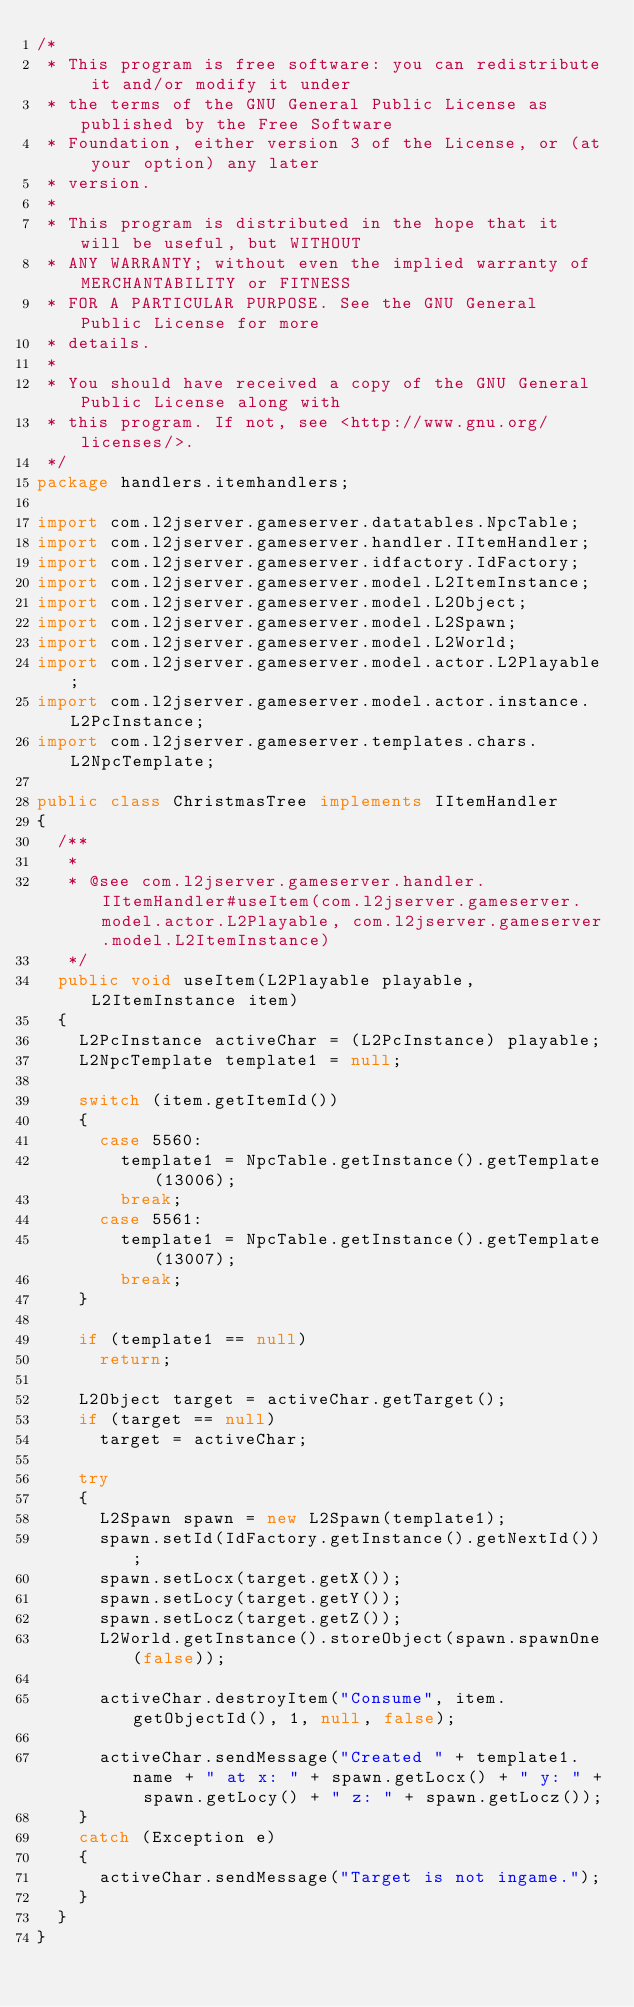<code> <loc_0><loc_0><loc_500><loc_500><_Java_>/*
 * This program is free software: you can redistribute it and/or modify it under
 * the terms of the GNU General Public License as published by the Free Software
 * Foundation, either version 3 of the License, or (at your option) any later
 * version.
 * 
 * This program is distributed in the hope that it will be useful, but WITHOUT
 * ANY WARRANTY; without even the implied warranty of MERCHANTABILITY or FITNESS
 * FOR A PARTICULAR PURPOSE. See the GNU General Public License for more
 * details.
 * 
 * You should have received a copy of the GNU General Public License along with
 * this program. If not, see <http://www.gnu.org/licenses/>.
 */
package handlers.itemhandlers;

import com.l2jserver.gameserver.datatables.NpcTable;
import com.l2jserver.gameserver.handler.IItemHandler;
import com.l2jserver.gameserver.idfactory.IdFactory;
import com.l2jserver.gameserver.model.L2ItemInstance;
import com.l2jserver.gameserver.model.L2Object;
import com.l2jserver.gameserver.model.L2Spawn;
import com.l2jserver.gameserver.model.L2World;
import com.l2jserver.gameserver.model.actor.L2Playable;
import com.l2jserver.gameserver.model.actor.instance.L2PcInstance;
import com.l2jserver.gameserver.templates.chars.L2NpcTemplate;

public class ChristmasTree implements IItemHandler
{
	/**
	 * 
	 * @see com.l2jserver.gameserver.handler.IItemHandler#useItem(com.l2jserver.gameserver.model.actor.L2Playable, com.l2jserver.gameserver.model.L2ItemInstance)
	 */
	public void useItem(L2Playable playable, L2ItemInstance item)
	{
		L2PcInstance activeChar = (L2PcInstance) playable;
		L2NpcTemplate template1 = null;
		
		switch (item.getItemId())
		{
			case 5560:
				template1 = NpcTable.getInstance().getTemplate(13006);
				break;
			case 5561:
				template1 = NpcTable.getInstance().getTemplate(13007);
				break;
		}
		
		if (template1 == null)
			return;
		
		L2Object target = activeChar.getTarget();
		if (target == null)
			target = activeChar;
		
		try
		{
			L2Spawn spawn = new L2Spawn(template1);
			spawn.setId(IdFactory.getInstance().getNextId());
			spawn.setLocx(target.getX());
			spawn.setLocy(target.getY());
			spawn.setLocz(target.getZ());
			L2World.getInstance().storeObject(spawn.spawnOne(false));
			
			activeChar.destroyItem("Consume", item.getObjectId(), 1, null, false);
			
			activeChar.sendMessage("Created " + template1.name + " at x: " + spawn.getLocx() + " y: " + spawn.getLocy() + " z: " + spawn.getLocz());
		}
		catch (Exception e)
		{
			activeChar.sendMessage("Target is not ingame.");
		}
	}
}
</code> 